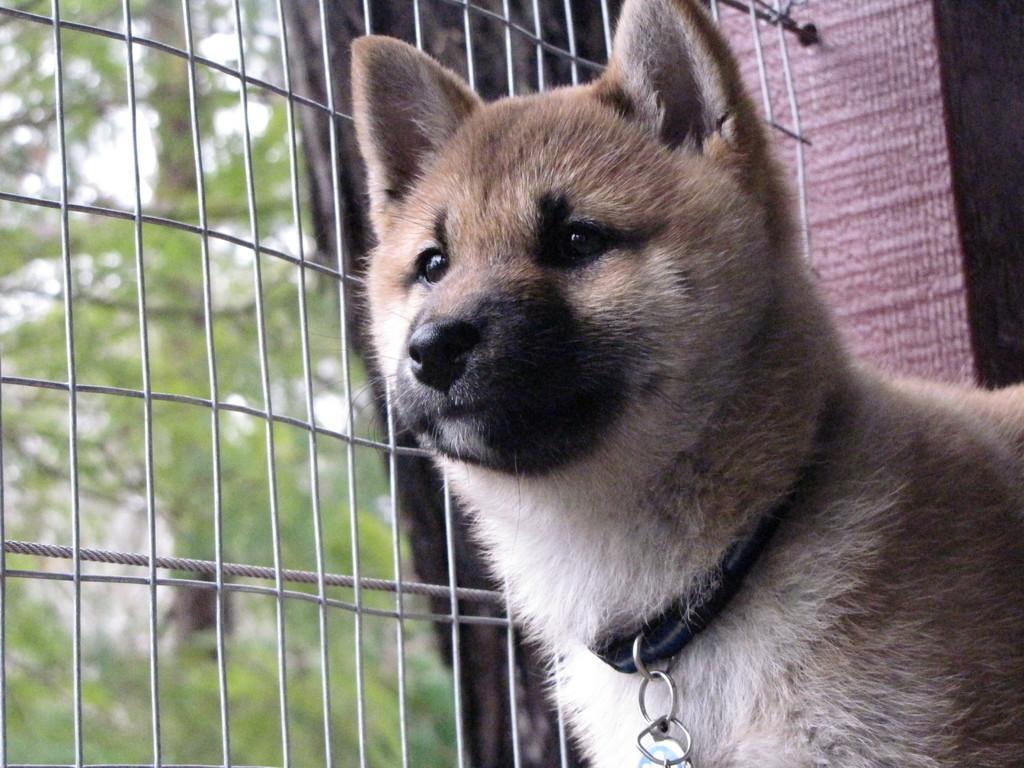Can you describe this image briefly? In this image we can see one dog with black belt, one object on the ground, one fence attached to the wall and some trees on the ground. 